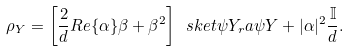Convert formula to latex. <formula><loc_0><loc_0><loc_500><loc_500>\rho _ { Y } = \left [ \frac { 2 } { d } R e \{ \alpha \} \beta + \beta ^ { 2 } \right ] \ s k e t { \psi } Y _ { r } a { \psi } Y + | \alpha | ^ { 2 } \frac { \mathbb { I } } d .</formula> 